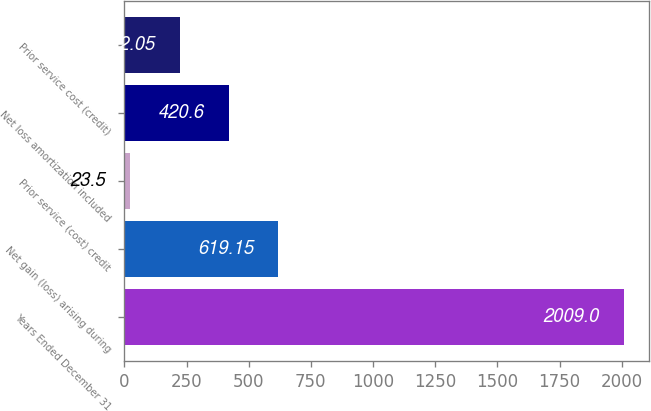Convert chart to OTSL. <chart><loc_0><loc_0><loc_500><loc_500><bar_chart><fcel>Years Ended December 31<fcel>Net gain (loss) arising during<fcel>Prior service (cost) credit<fcel>Net loss amortization included<fcel>Prior service cost (credit)<nl><fcel>2009<fcel>619.15<fcel>23.5<fcel>420.6<fcel>222.05<nl></chart> 